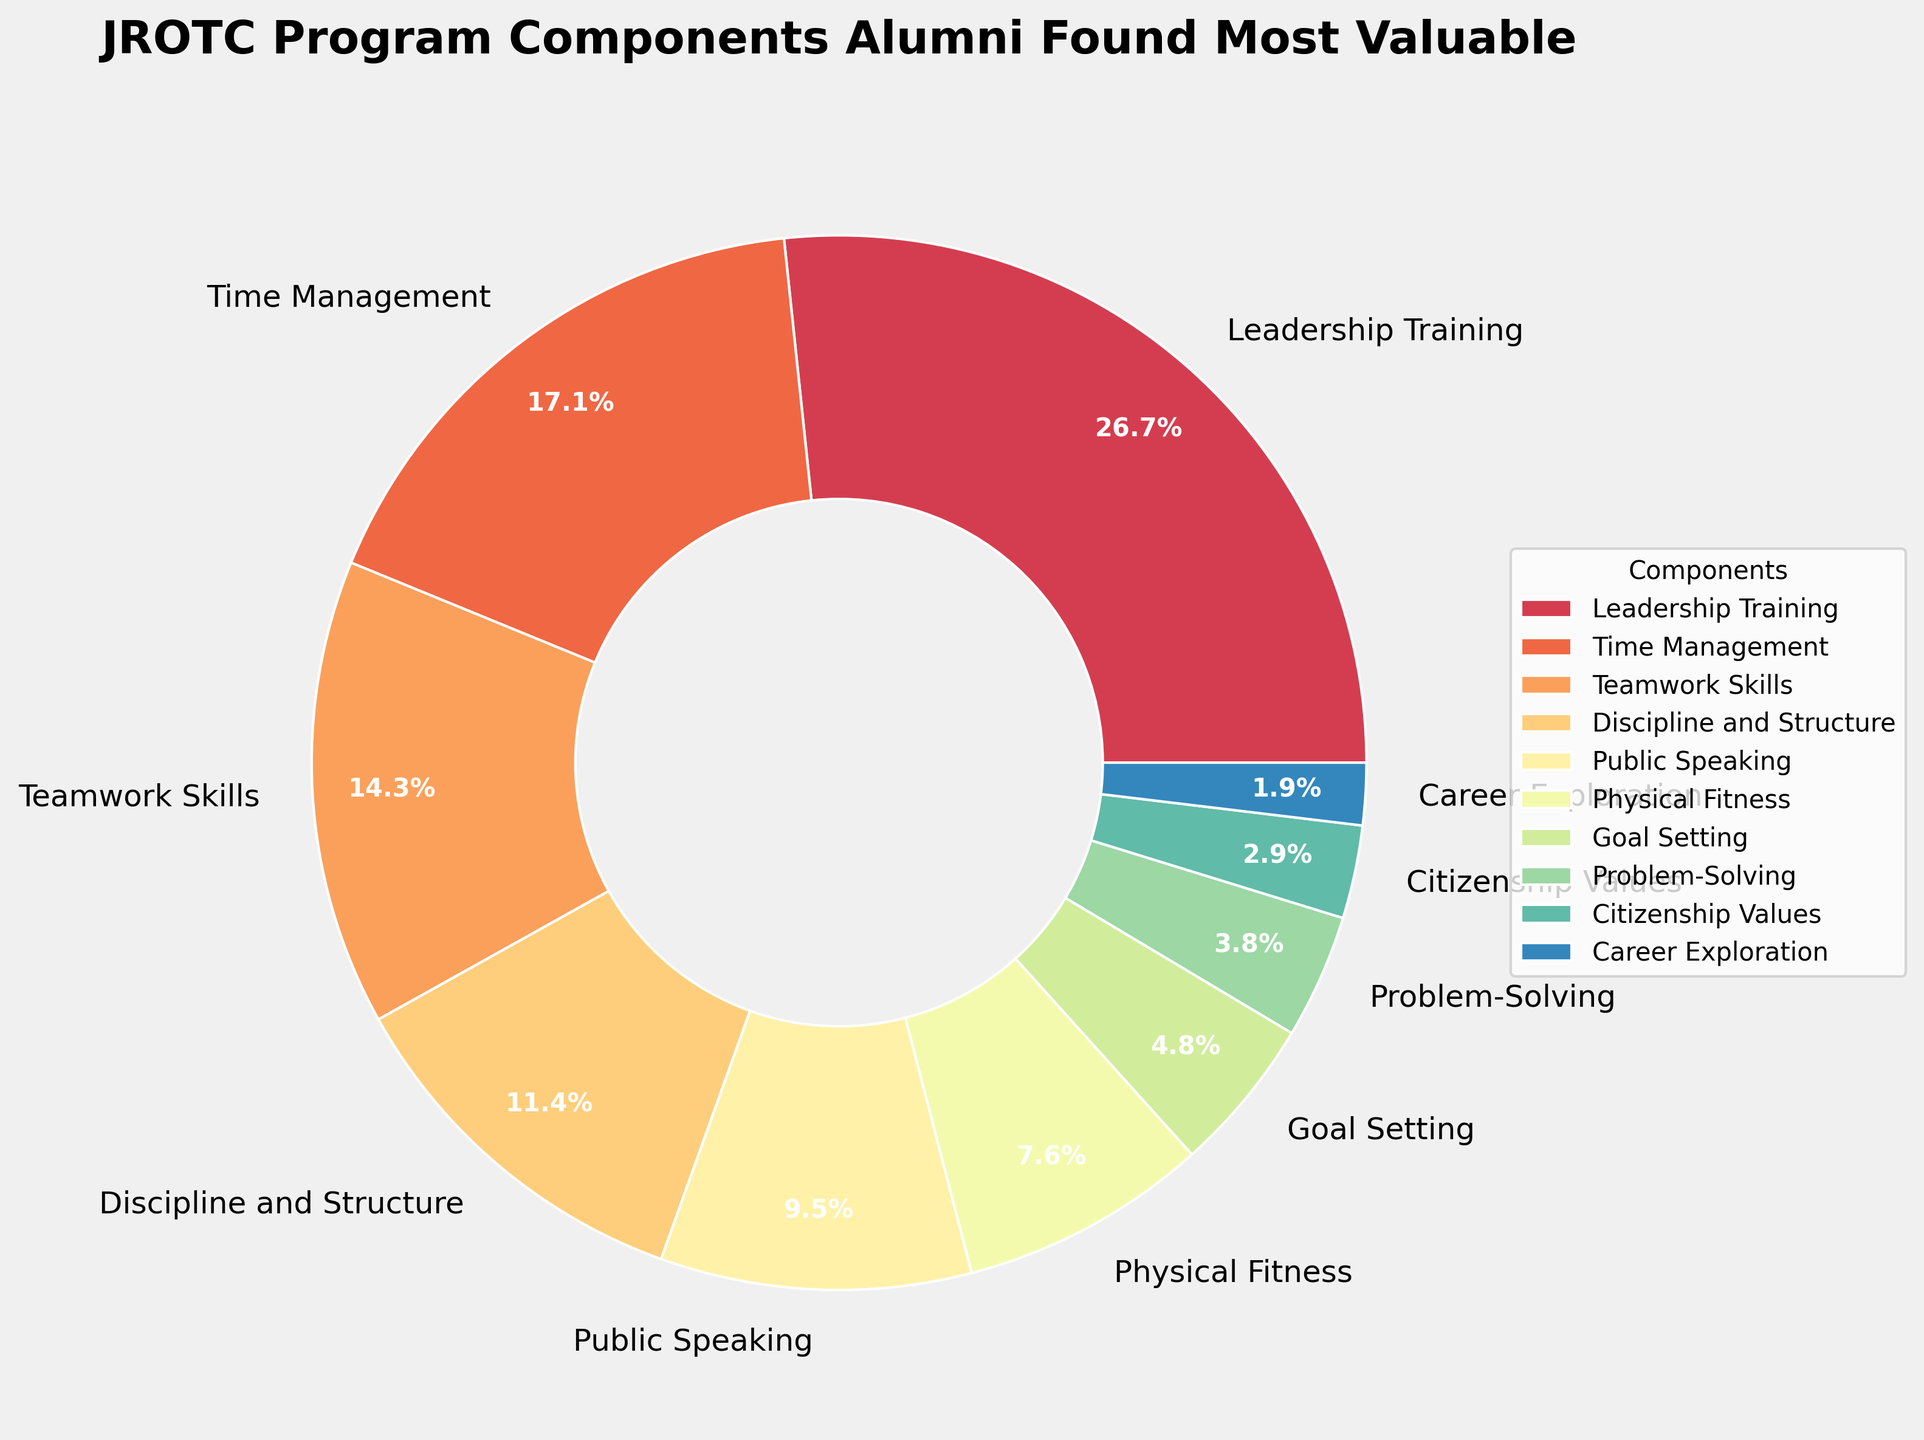Which JROTC program component did alumni find most valuable? To find the most valuable component according to alumni, we look for the component with the largest percentage in the pie chart. "Leadership Training" has the highest percentage at 28%.
Answer: Leadership Training Which two components combine to make up more than one-third of the total percentage? To determine which components combine to make up more than one-third of the total (more than 33.33%), we add the percentages of the components. "Leadership Training" is 28%, and "Time Management" is 18%. Their combined total is 46%, which is above one-third.
Answer: Leadership Training and Time Management How much more valuable is "Leadership Training" compared to "Teamwork Skills"? To compare the two components, we subtract the percentage of "Teamwork Skills" from "Leadership Training". "Leadership Training" is 28% and "Teamwork Skills" is 15%, so 28% - 15% = 13%.
Answer: 13% Which component represents the smallest percentage, and what is that percentage? To find the smallest component, we look for the component with the smallest slice and percentage. "Career Exploration" has the smallest percentage at 2%.
Answer: Career Exploration, 2% If you combine "Discipline and Structure", "Public Speaking", and "Physical Fitness", what is their total percentage? To find the total percentage, we sum the percentages of these three components: "Discipline and Structure" is 12%, "Public Speaking" is 10%, and "Physical Fitness" is 8%. Adding these gives 12% + 10% + 8% = 30%.
Answer: 30% Which component directly follows "Leadership Training" in terms of alumni value, and by what percentage is it less valuable? The component directly following "Leadership Training" is "Time Management" with 18%. The difference between "Leadership Training" (28%) and "Time Management" (18%) is 28% - 18% = 10%.
Answer: Time Management, 10% What's the combined percentage of all components that fall below 10%? To determine this, we sum the percentages of the components below 10%: "Physical Fitness" (8%), "Goal Setting" (5%), "Problem-Solving" (4%), "Citizenship Values" (3%), and "Career Exploration" (2%). Adding these, 8% + 5% + 4% + 3% + 2% = 22%.
Answer: 22% How many components have a percentage of 15% or higher? To answer this, count each component with a percentage of 15% or higher: "Leadership Training" (28%), "Time Management" (18%), and "Teamwork Skills" (15%). There are three.
Answer: 3 If you add the percentages of "Time Management" and "Public Speaking", do they exceed the percentage of "Leadership Training"? To determine this, add "Time Management" (18%) and "Public Speaking" (10%) to get 18% + 10% = 28%, which is equal to "Leadership Training".
Answer: No, they are equal 